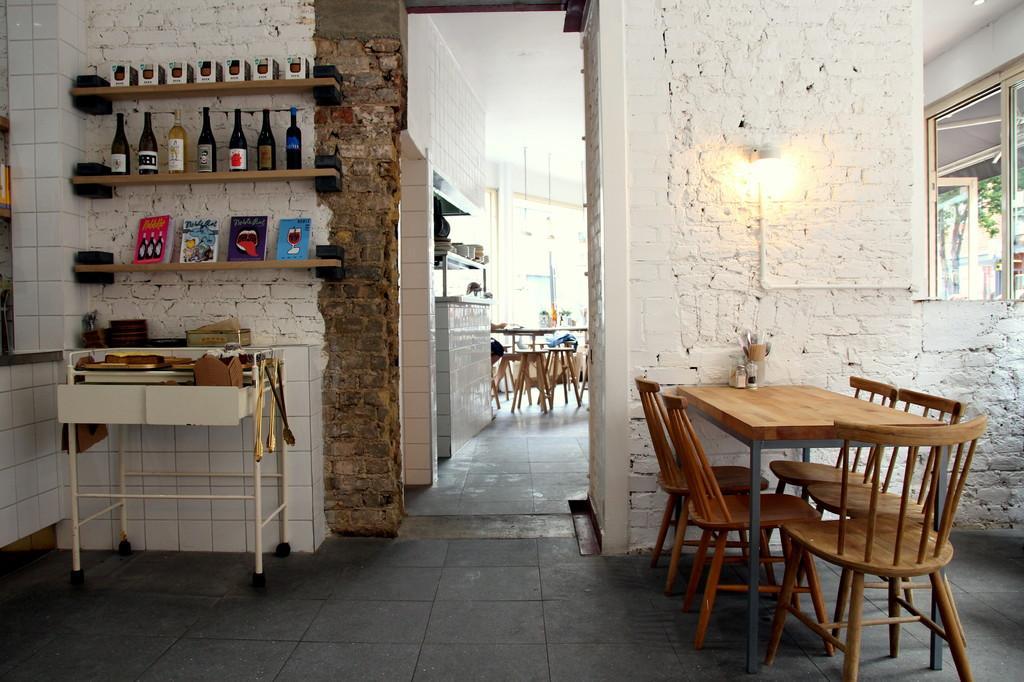Describe this image in one or two sentences. In this image there are racks, tables, chairs, walls, light, window, tile floor and objects. In that racks there are bottles and objects. On the tables there are things. Light is on the wall. 